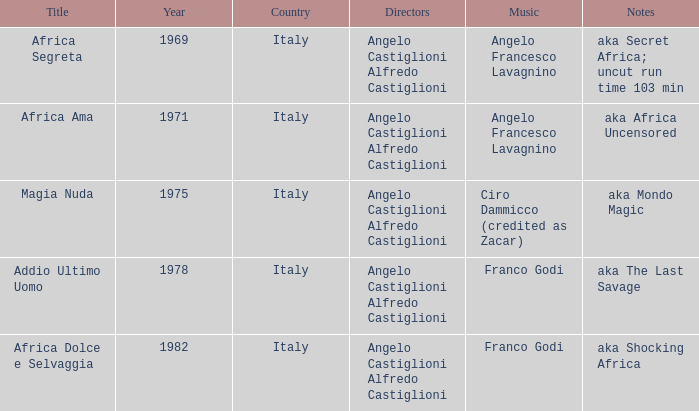What notes make up the melody of aka africa uncensored? Angelo Francesco Lavagnino. 